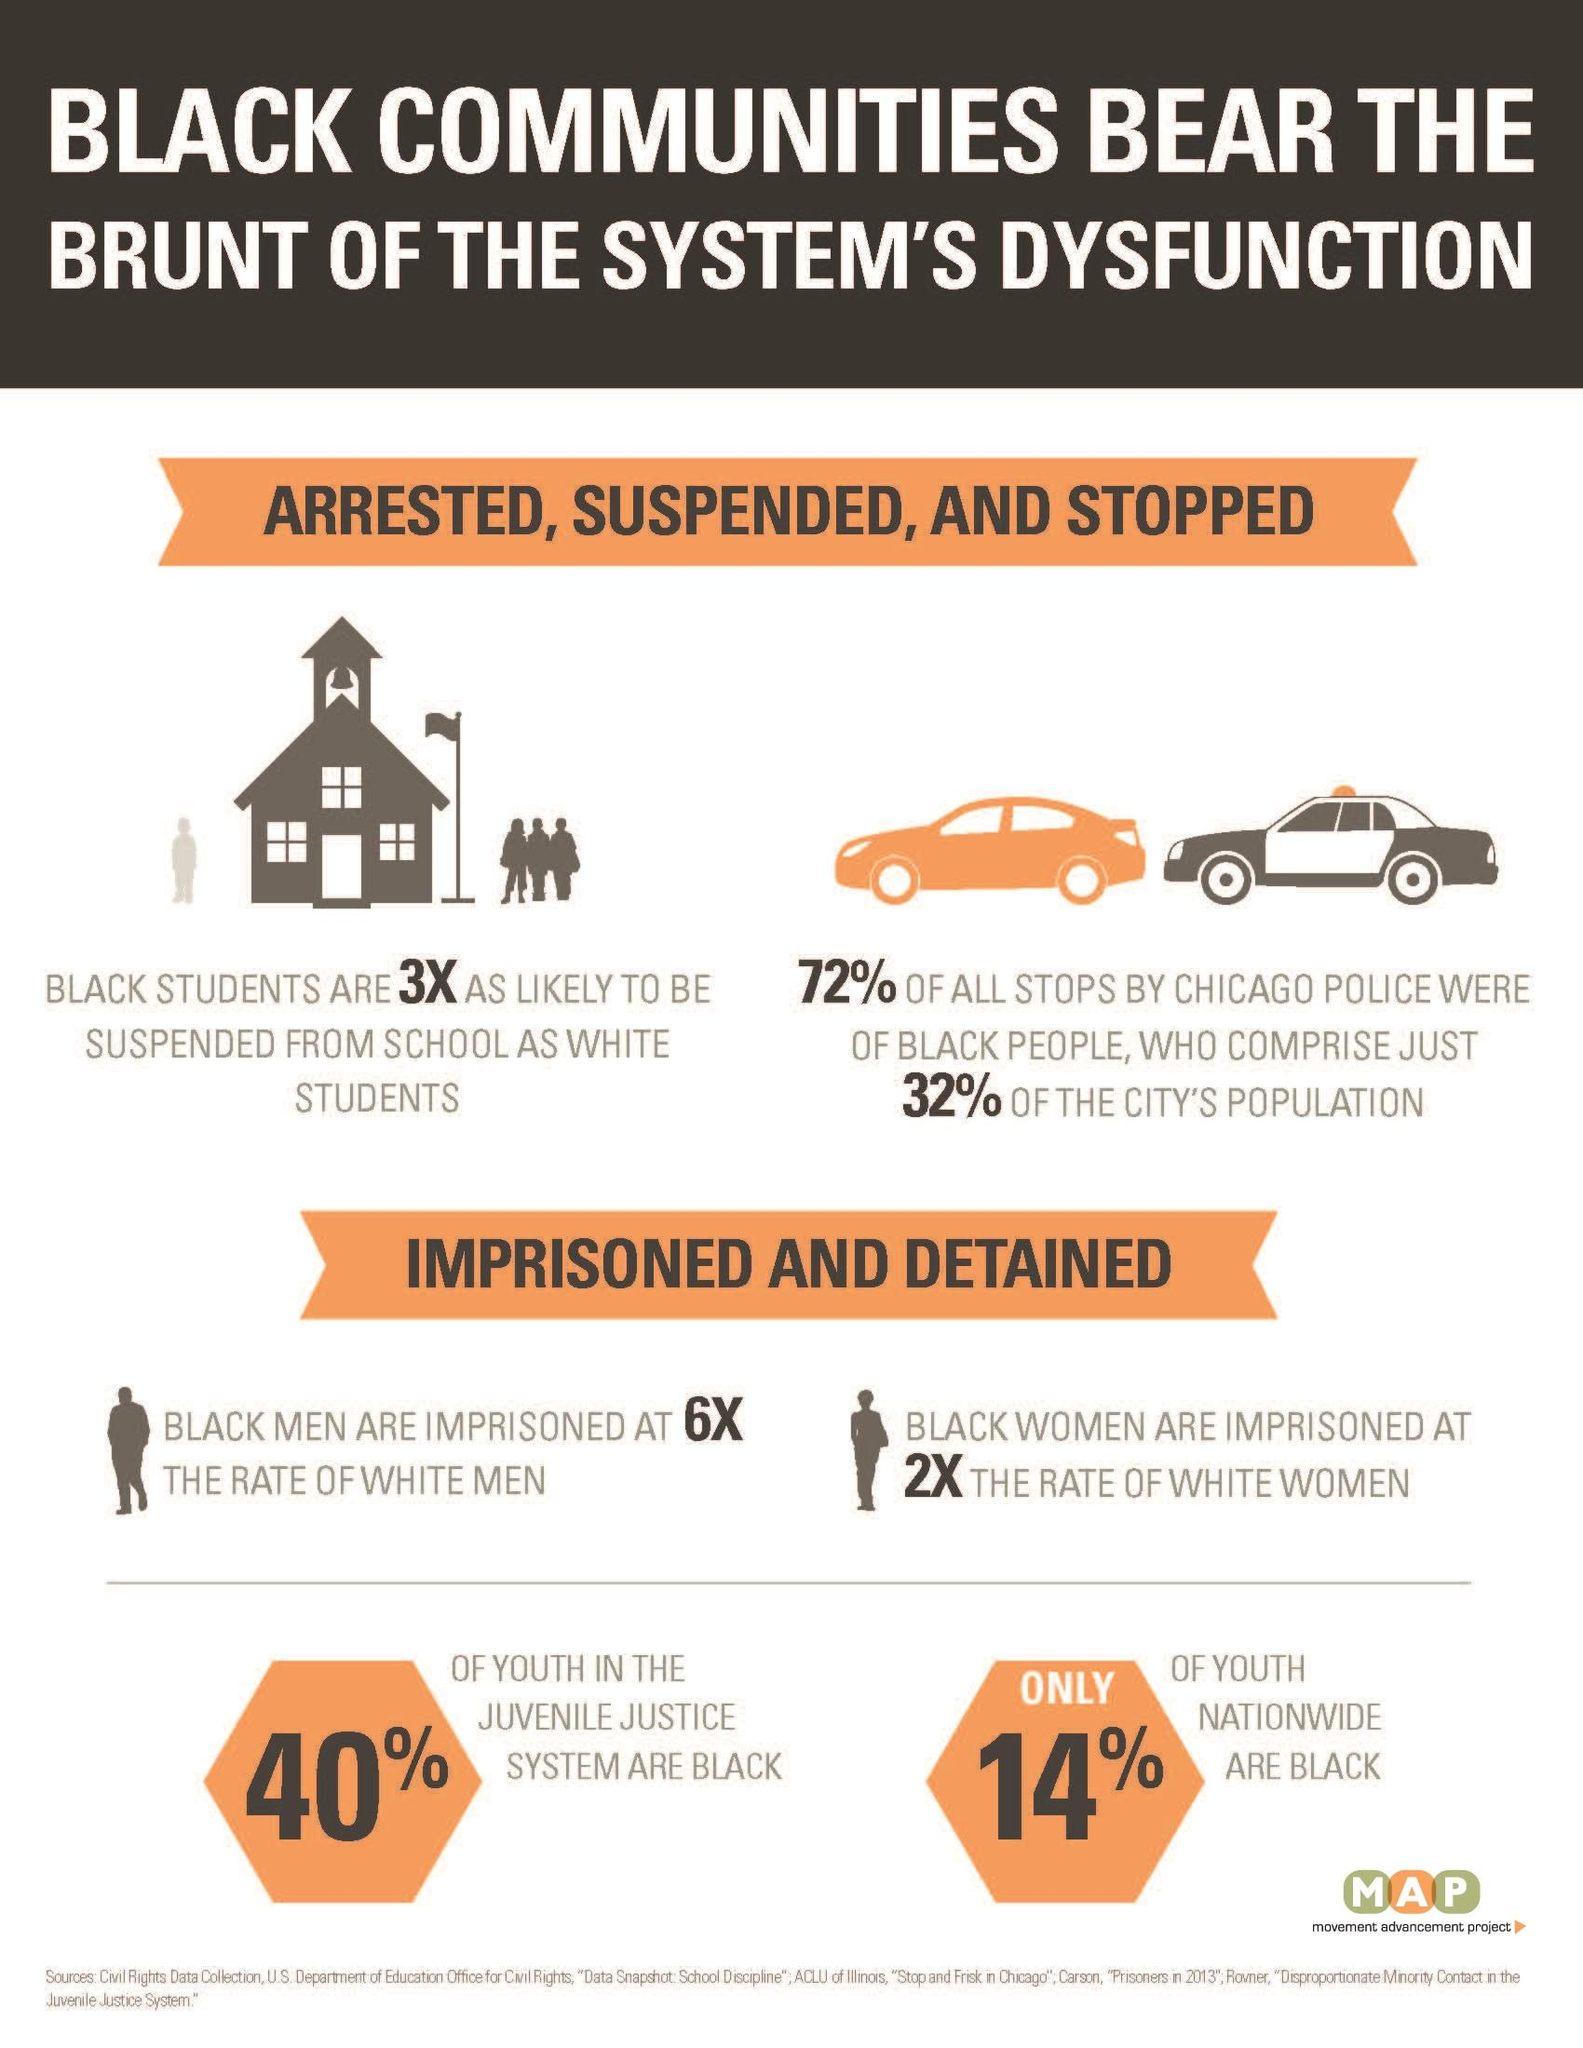Mention a couple of crucial points in this snapshot. According to data, only 40% of youth in the juvenile justice system are black, which is a significant decrease from previous years. According to a national survey, only 14% of youth in the United States are black. 